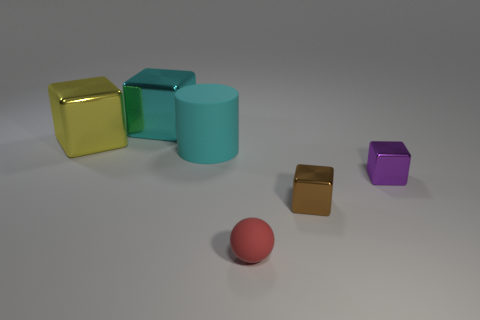What material is the large block that is the same color as the big matte object?
Provide a short and direct response. Metal. There is a matte thing that is behind the small sphere; is its size the same as the rubber thing in front of the large cylinder?
Make the answer very short. No. There is a large cyan object that is left of the big rubber object; what is its shape?
Offer a terse response. Cube. What is the material of the big cyan object that is the same shape as the tiny purple metallic thing?
Offer a very short reply. Metal. There is a metal thing that is in front of the purple shiny cube; is it the same size as the tiny matte object?
Give a very brief answer. Yes. What number of small spheres are left of the cyan rubber object?
Give a very brief answer. 0. Are there fewer brown blocks on the left side of the yellow thing than matte balls on the right side of the cylinder?
Your answer should be compact. Yes. How many metallic objects are there?
Provide a short and direct response. 4. The matte object to the left of the red sphere is what color?
Provide a succinct answer. Cyan. What size is the brown metal thing?
Provide a short and direct response. Small. 